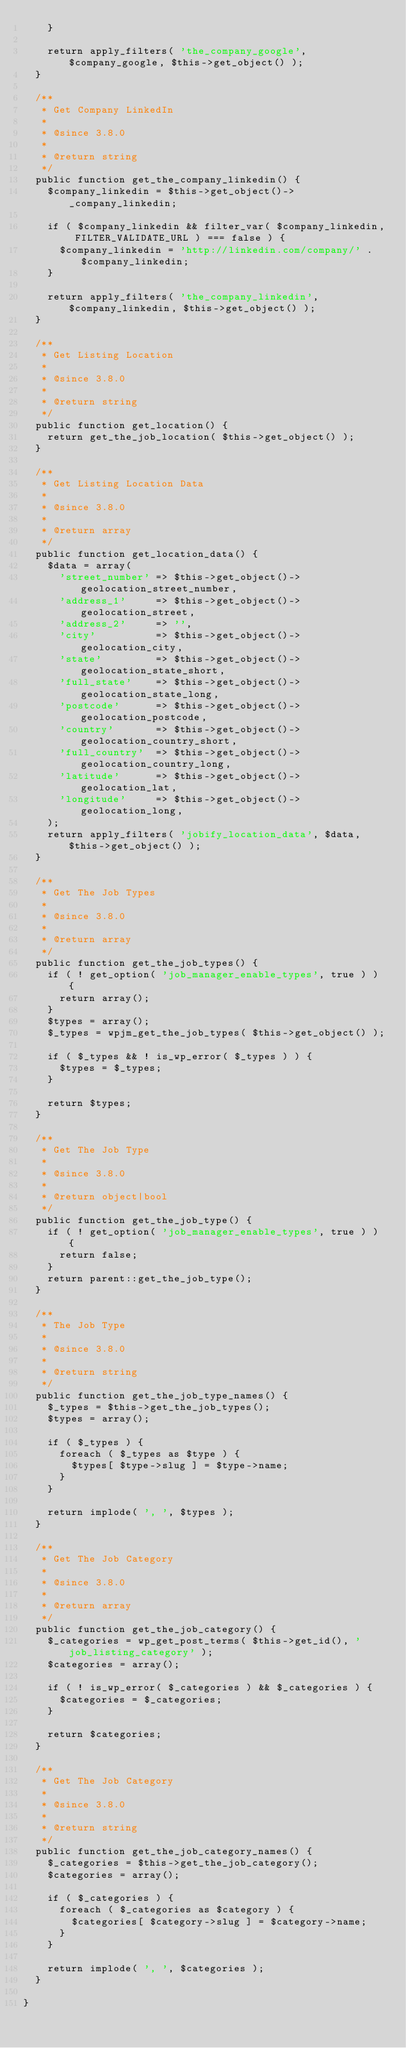Convert code to text. <code><loc_0><loc_0><loc_500><loc_500><_PHP_>		}

		return apply_filters( 'the_company_google', $company_google, $this->get_object() );
	}

	/**
	 * Get Company LinkedIn
	 *
	 * @since 3.8.0
	 *
	 * @return string
	 */
	public function get_the_company_linkedin() {
		$company_linkedin = $this->get_object()->_company_linkedin;

		if ( $company_linkedin && filter_var( $company_linkedin, FILTER_VALIDATE_URL ) === false ) {
			$company_linkedin = 'http://linkedin.com/company/' . $company_linkedin;
		}

		return apply_filters( 'the_company_linkedin', $company_linkedin, $this->get_object() );
	}

	/**
	 * Get Listing Location
	 *
	 * @since 3.8.0
	 *
	 * @return string
	 */
	public function get_location() {
		return get_the_job_location( $this->get_object() );
	}

	/**
	 * Get Listing Location Data
	 *
	 * @since 3.8.0
	 *
	 * @return array
	 */
	public function get_location_data() {
		$data = array(
			'street_number' => $this->get_object()->geolocation_street_number,
			'address_1'     => $this->get_object()->geolocation_street,
			'address_2'     => '',
			'city'          => $this->get_object()->geolocation_city,
			'state'         => $this->get_object()->geolocation_state_short,
			'full_state'    => $this->get_object()->geolocation_state_long,
			'postcode'      => $this->get_object()->geolocation_postcode,
			'country'       => $this->get_object()->geolocation_country_short,
			'full_country'  => $this->get_object()->geolocation_country_long,
			'latitude'      => $this->get_object()->geolocation_lat,
			'longitude'     => $this->get_object()->geolocation_long,
		);
		return apply_filters( 'jobify_location_data', $data, $this->get_object() );
	}

	/**
	 * Get The Job Types
	 *
	 * @since 3.8.0
	 *
	 * @return array
	 */
	public function get_the_job_types() {
		if ( ! get_option( 'job_manager_enable_types', true ) ) {
			return array();
		}
		$types = array();
		$_types = wpjm_get_the_job_types( $this->get_object() );

		if ( $_types && ! is_wp_error( $_types ) ) {
			$types = $_types;
		}

		return $types;
	}

	/**
	 * Get The Job Type
	 *
	 * @since 3.8.0
	 *
	 * @return object|bool
	 */
	public function get_the_job_type() {
		if ( ! get_option( 'job_manager_enable_types', true ) ) {
			return false;
		}
		return parent::get_the_job_type();
	}

	/**
	 * The Job Type
	 *
	 * @since 3.8.0
	 *
	 * @return string
	 */
	public function get_the_job_type_names() {
		$_types = $this->get_the_job_types();
		$types = array();

		if ( $_types ) {
			foreach ( $_types as $type ) {
				$types[ $type->slug ] = $type->name;
			}
		}

		return implode( ', ', $types );
	}

	/**
	 * Get The Job Category
	 *
	 * @since 3.8.0
	 *
	 * @return array
	 */
	public function get_the_job_category() {
		$_categories = wp_get_post_terms( $this->get_id(), 'job_listing_category' );
		$categories = array();

		if ( ! is_wp_error( $_categories ) && $_categories ) {
			$categories = $_categories;
		}

		return $categories;
	}

	/**
	 * Get The Job Category
	 *
	 * @since 3.8.0
	 *
	 * @return string
	 */
	public function get_the_job_category_names() {
		$_categories = $this->get_the_job_category();
		$categories = array();

		if ( $_categories ) {
			foreach ( $_categories as $category ) {
				$categories[ $category->slug ] = $category->name;
			}
		}

		return implode( ', ', $categories );
	}

}
</code> 